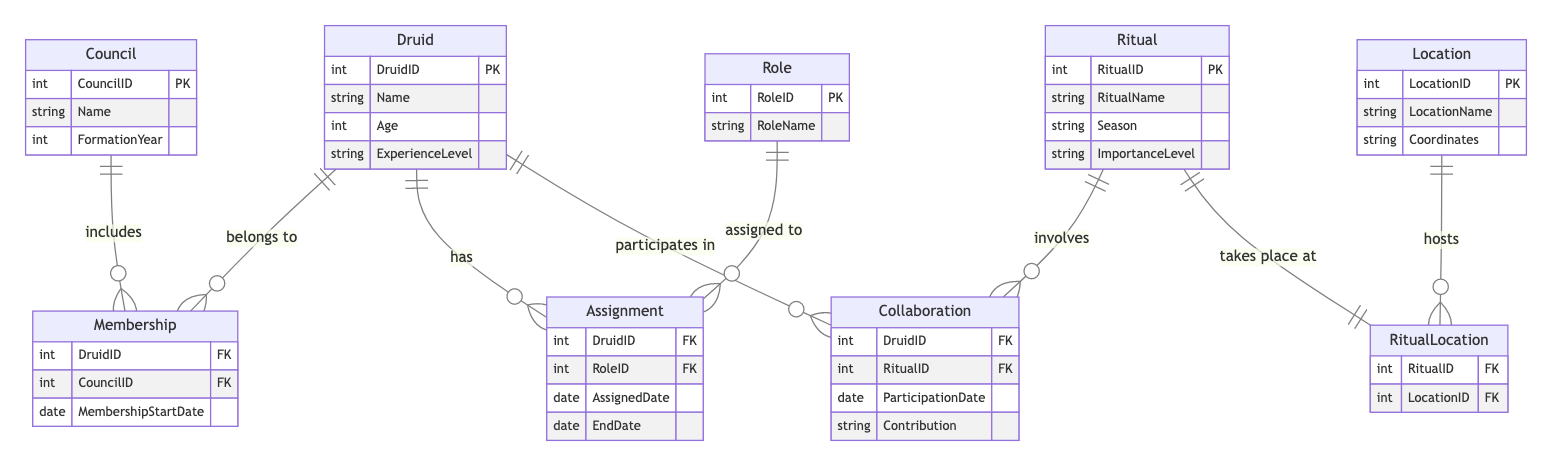What is the primary key of the Druid entity? The primary key of the Druid entity is DruidID, which uniquely identifies each Druid in the community.
Answer: DruidID How many relationships does the Druid entity have? The Druid entity has three relationships: Membership, Assignment, and Collaboration, indicating its involvement with councils, roles, and rituals respectively.
Answer: 3 Which entity has the relationship name "Collaboration"? The relationship named "Collaboration" involves the Druid entity and the Ritual entity, indicating that Druids participate in rituals.
Answer: Ritual What attributes are associated with the Council entity? The Council entity includes attributes such as CouncilID, Name, and FormationYear, which provide details about the council.
Answer: CouncilID, Name, FormationYear What is the importance of the Role entity in relation to the Druid entity? The Role entity is important as it defines the various roles assigned to Druids through the Assignment relationship, indicating their specific functions within the community.
Answer: Assignment Which two entities are connected through the RitualLocation relationship? The RitualLocation relationship connects the Ritual and Location entities, showing that rituals take place at specific locations.
Answer: Ritual, Location How many attributes does the Ritual entity have? The Ritual entity has four attributes: RitualID, RitualName, Season, and ImportanceLevel, which describe the various aspects of each ritual.
Answer: 4 What does the Membership relationship convey about Druids and Councils? The Membership relationship indicates that each Druid belongs to a Council, and vice versa, showing a hierarchical structure within the community.
Answer: Belongs to What kind of information does the Collaboration relationship provide? The Collaboration relationship provides information about Druids' participation in rituals, including the ParticipationDate and Contribution made by each Druid, highlighting their engagement in communal activities.
Answer: ParticipationDate, Contribution 